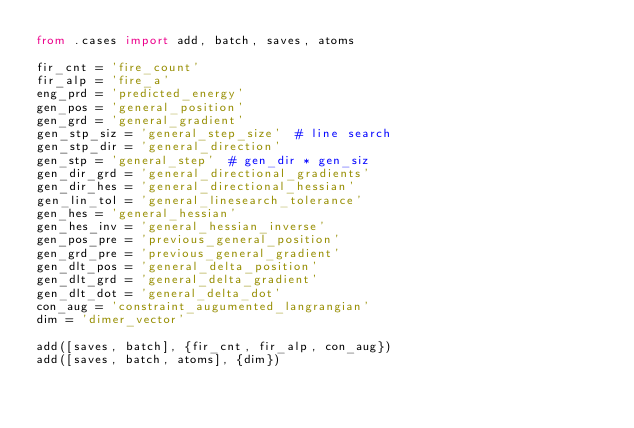Convert code to text. <code><loc_0><loc_0><loc_500><loc_500><_Python_>from .cases import add, batch, saves, atoms

fir_cnt = 'fire_count'
fir_alp = 'fire_a'
eng_prd = 'predicted_energy'
gen_pos = 'general_position'
gen_grd = 'general_gradient'
gen_stp_siz = 'general_step_size'  # line search
gen_stp_dir = 'general_direction'
gen_stp = 'general_step'  # gen_dir * gen_siz
gen_dir_grd = 'general_directional_gradients'
gen_dir_hes = 'general_directional_hessian'
gen_lin_tol = 'general_linesearch_tolerance'
gen_hes = 'general_hessian'
gen_hes_inv = 'general_hessian_inverse'
gen_pos_pre = 'previous_general_position'
gen_grd_pre = 'previous_general_gradient'
gen_dlt_pos = 'general_delta_position'
gen_dlt_grd = 'general_delta_gradient'
gen_dlt_dot = 'general_delta_dot'
con_aug = 'constraint_augumented_langrangian'
dim = 'dimer_vector'

add([saves, batch], {fir_cnt, fir_alp, con_aug})
add([saves, batch, atoms], {dim})
</code> 